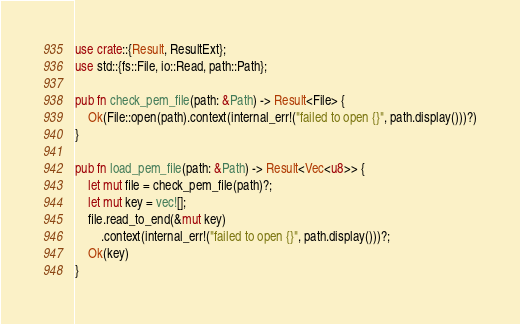<code> <loc_0><loc_0><loc_500><loc_500><_Rust_>use crate::{Result, ResultExt};
use std::{fs::File, io::Read, path::Path};

pub fn check_pem_file(path: &Path) -> Result<File> {
    Ok(File::open(path).context(internal_err!("failed to open {}", path.display()))?)
}

pub fn load_pem_file(path: &Path) -> Result<Vec<u8>> {
    let mut file = check_pem_file(path)?;
    let mut key = vec![];
    file.read_to_end(&mut key)
        .context(internal_err!("failed to open {}", path.display()))?;
    Ok(key)
}
</code> 